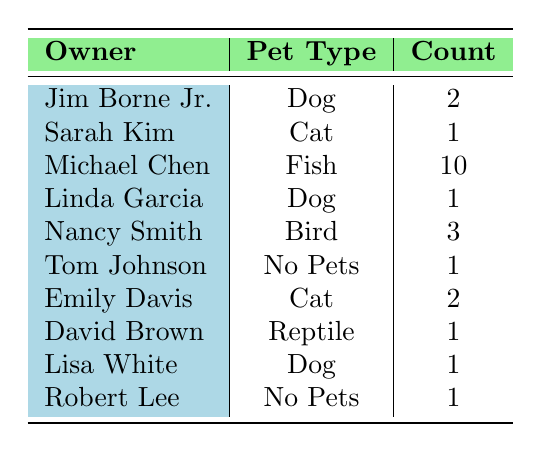What is the total number of pets owned in the households listed? To find the total number of pets, we need to sum the counts from each household. The individual counts are: 2 (Jim Borne Jr.) + 1 (Sarah Kim) + 10 (Michael Chen) + 1 (Linda Garcia) + 3 (Nancy Smith) + 1 (Tom Johnson) + 2 (Emily Davis) + 1 (David Brown) + 1 (Lisa White) + 1 (Robert Lee). Adding these together gives us a total of 22 pets.
Answer: 22 How many households own a dog? To find out how many households own a dog, we look at the "Pet Type" column for the entries that show "Dog." The households with dogs are Jim Borne Jr., Linda Garcia, and Lisa White. Counting these, we find there are 3 households that own a dog.
Answer: 3 Which pet type has the highest count? We compare the counts of each pet type. The counts are: Dog (2 + 1 + 1 = 4), Cat (1 + 2 = 3), Fish (10), Bird (3), Reptile (1), and No Pets (1 + 1 = 2). The pet type with the highest count is Fish, with a total count of 10.
Answer: Fish Are there any households without pets? We can identify the households that have "No Pets" listed under "Pet Type." The households are Tom Johnson and Robert Lee. Since there are entries in the table indicating households with "No Pets," the answer is yes.
Answer: Yes What is the average number of count for households that own cats? We first identify the households that own cats: Sarah Kim (1) and Emily Davis (2). To find the average, we can sum their counts (1 + 2) and divide by the number of households (2). The total is 3, and the average count is 3 / 2 = 1.5.
Answer: 1.5 How many more pets does Michael Chen own compared to the household with the second-highest pet count? Michael Chen owns 10 fish, which is the highest count. The second-highest count is 3 (Nancy Smith's birds). To find the difference, we calculate 10 - 3 = 7. Therefore, Michael Chen owns 7 more pets than the second-highest household.
Answer: 7 Is there at least one household that owns a reptile? Looking through the table, there is a household listed with a reptile: David Brown. Thus, we can confirm that there is at least one household that owns a reptile.
Answer: Yes What is the total count of birds and fish owned in the community? We need to find the counts for birds and fish. From the table, Nancy Smith owns 3 birds, and Michael Chen owns 10 fish. Adding these together gives us 3 + 10 = 13.
Answer: 13 How many households have a pet that isn't a cat or a dog? We examine the table for households that own pets other than cats and dogs. The pet types that fit this description are Fish (Michael Chen), Bird (Nancy Smith), and Reptile (David Brown). Counting these, we find 3 households.
Answer: 3 